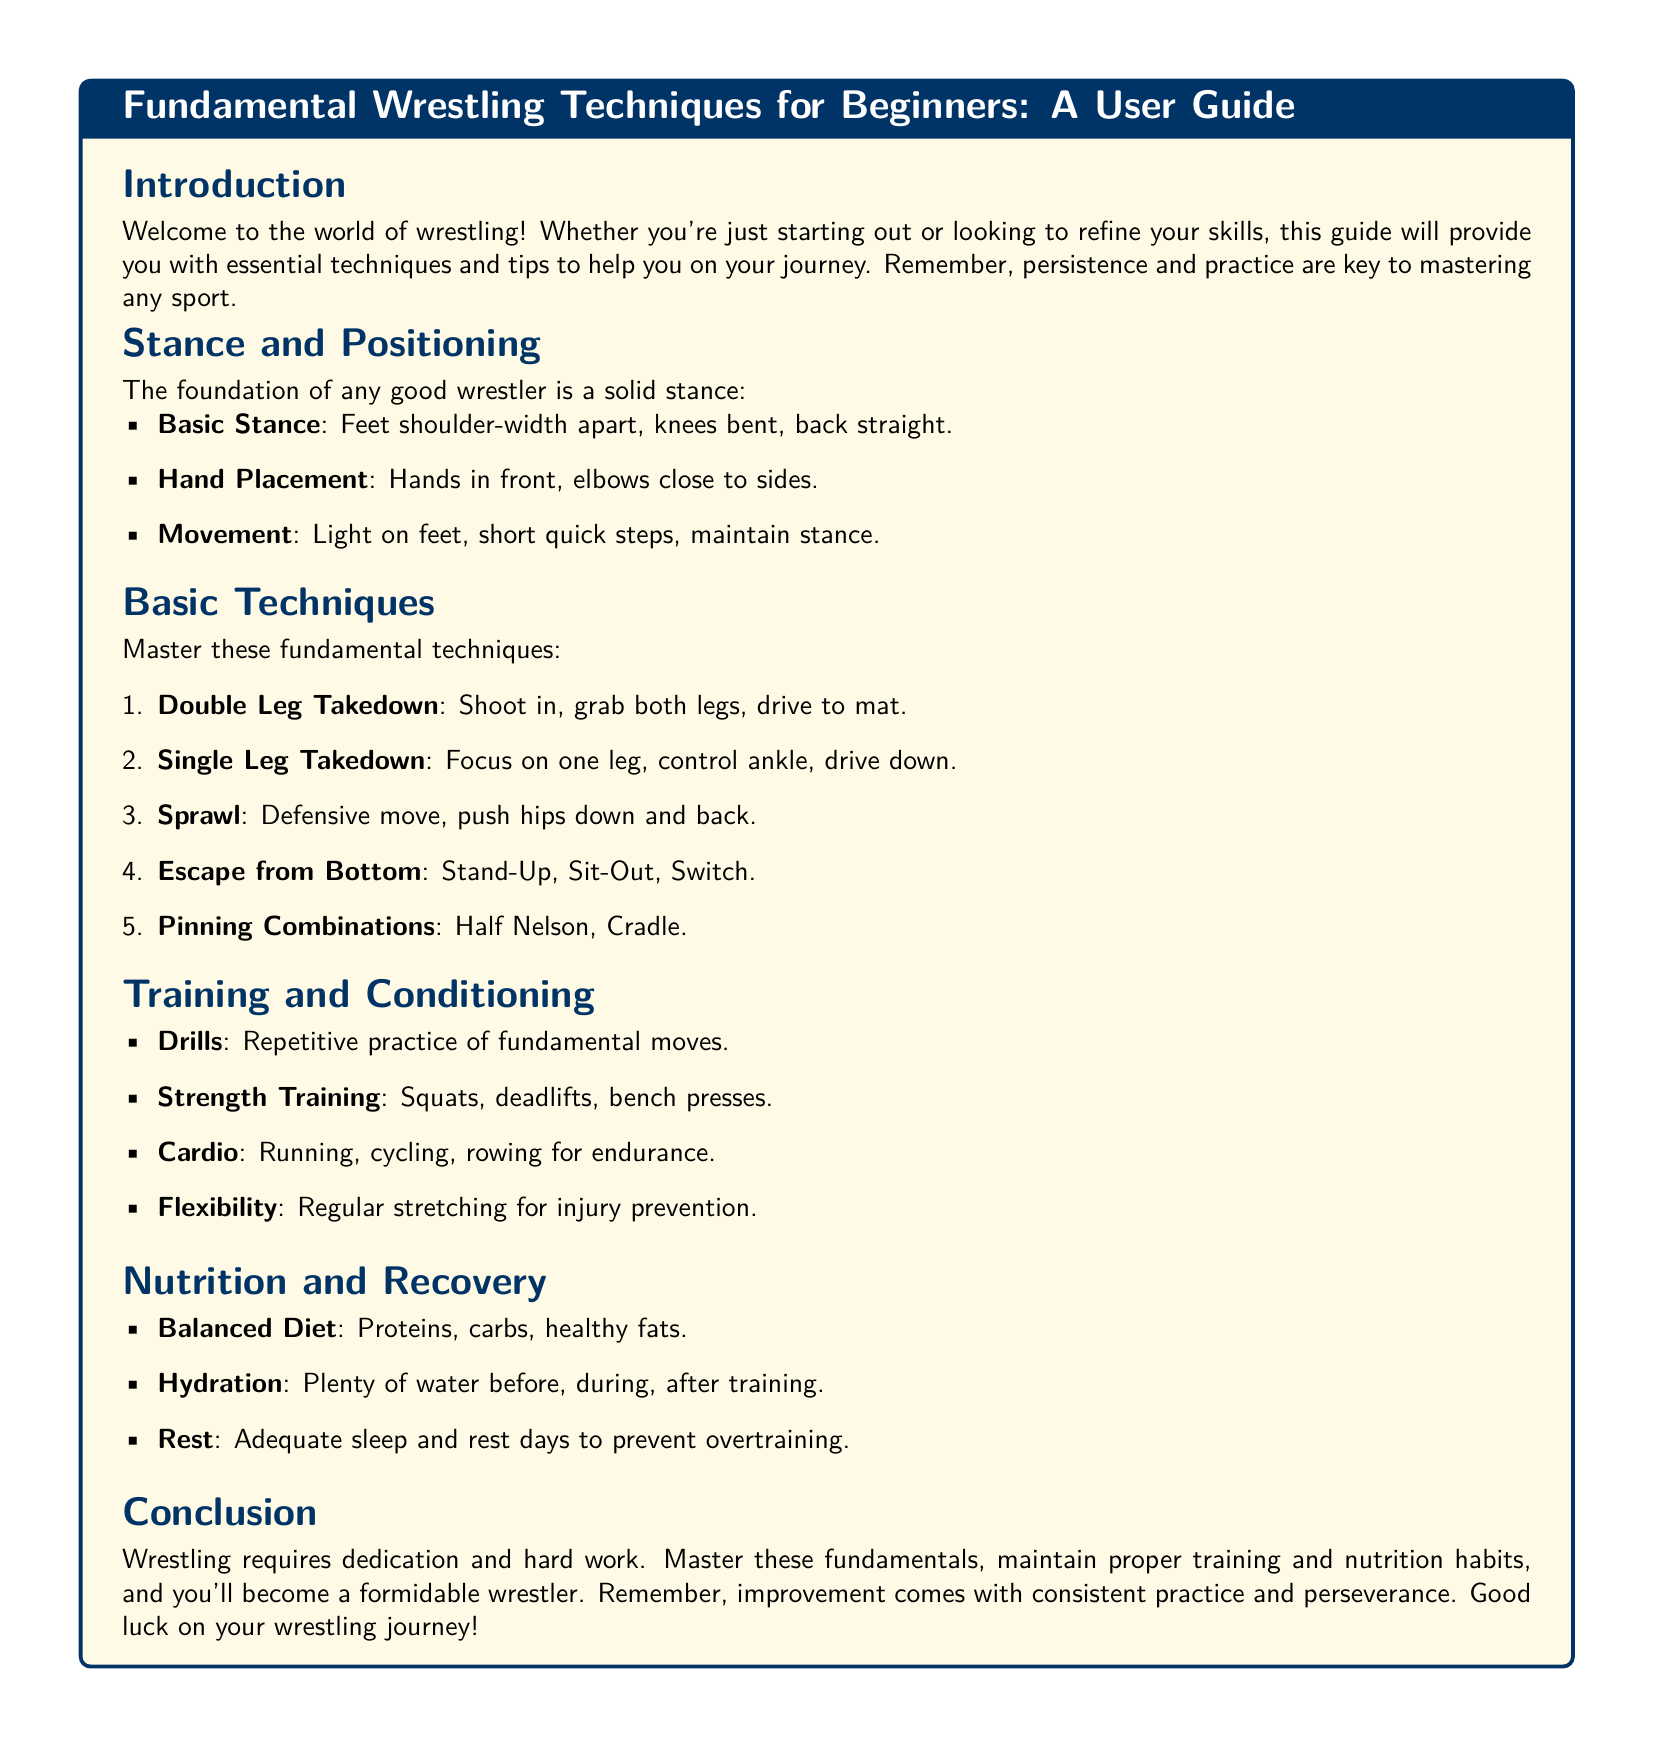What is the title of the guide? The title is explicitly mentioned at the top of the document in a highlighted box.
Answer: Fundamental Wrestling Techniques for Beginners: A User Guide What is a basic stance? The document provides specific details about the basic stance as part of the stance and positioning section.
Answer: Feet shoulder-width apart, knees bent, back straight What are the first three basic techniques listed? The first three techniques are outlined in a numbered list in the basic techniques section.
Answer: Double Leg Takedown, Single Leg Takedown, Sprawl What type of training is recommended for endurance? The document suggests various forms of training under the training and conditioning section.
Answer: Running, cycling, rowing How many types of escape techniques are mentioned? The list in the basic techniques section provides a specific number of escape techniques.
Answer: Three (Stand-Up, Sit-Out, Switch) What is emphasized for injury prevention? The document outlines various aspects of training and conditioning, highlighting a specific practice for injury prevention.
Answer: Regular stretching What is included in the balanced diet suggested? The document lists components of a balanced diet under the nutrition and recovery section.
Answer: Proteins, carbs, healthy fats What should a wrestler do for hydration? The hydration advice is clearly stated in the nutrition and recovery section of the document.
Answer: Plenty of water before, during, after training What is the main theme of the conclusion? The conclusion reiterates key points from the guide and summarizes the essential takeaway about the nature of wrestling.
Answer: Dedication and hard work 